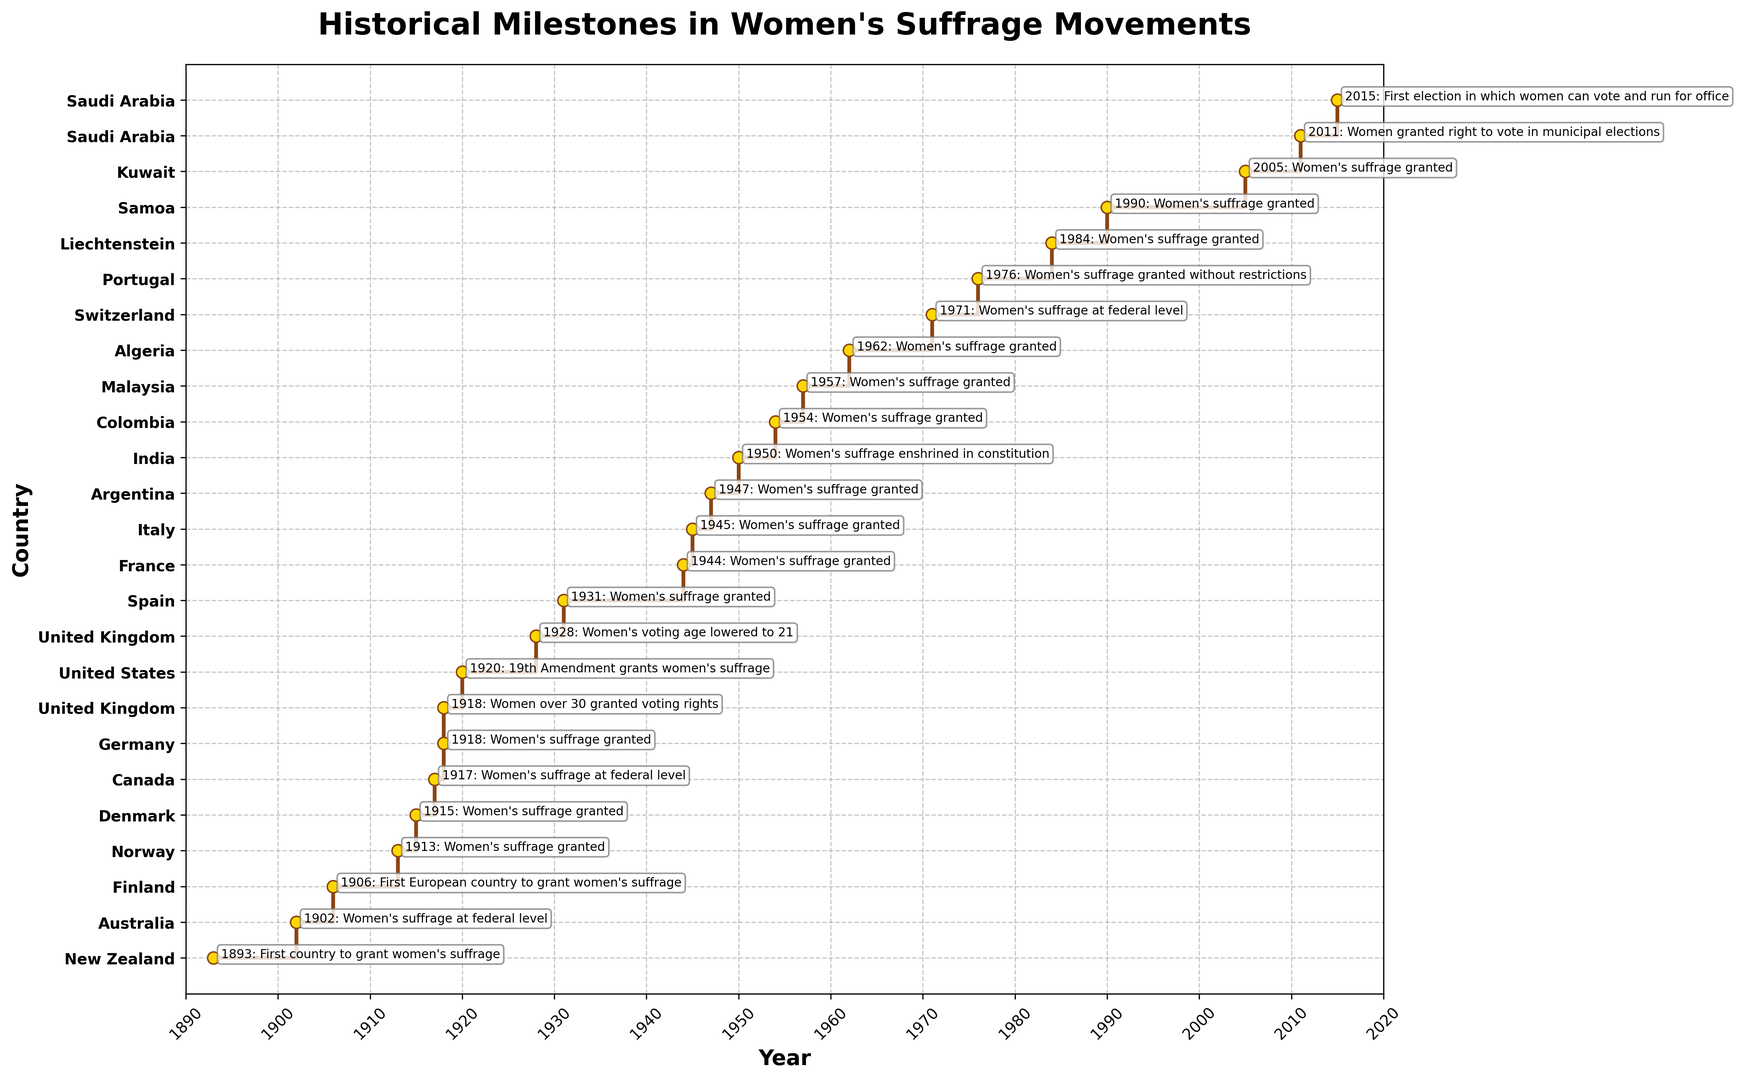Which country was the first to grant women's suffrage? By looking at the earliest year on the y-axis, which is 1893, and checking the country associated with it, we see that it is New Zealand.
Answer: New Zealand In which year did women gain the right to vote for municipal elections in Saudi Arabia? From the timeline, we can find Saudi Arabia and then read the year associated with the milestone "Women granted right to vote in municipal elections", which is 2011.
Answer: 2011 Which country granted women's suffrage at the federal level last, and in what year? By looking at the countries and the descriptions (historical milestones) on the y-axis, the country which granted suffrage last at the federal level is Switzerland in 1971.
Answer: Switzerland, 1971 How many years passed between the first country to grant women's suffrage and when the United States granted it? Identify the years for New Zealand (1893) and the United States (1920), and subtract the earlier year from the later year: 1920 - 1893 = 27 years.
Answer: 27 years In what year did both Germany and the United Kingdom have milestones related to women's suffrage, and what were those milestones? Check the row for the year 1918 and see both Germany and the United Kingdom there. Germany granted women's suffrage, and the United Kingdom granted voting rights to women over 30.
Answer: 1918; Germany granted women's suffrage, the UK granted voting rights to women over 30 How many countries granted women's suffrage between 1900 and 1950? Count the number of countries associated with years between 1900 and 1950 inclusive. These countries are Australia (1902), Finland (1906), Norway (1913), Denmark (1915), Canada (1917), Germany (1918), United Kingdom (1918, 1928), United States (1920), Spain (1931), France (1944), Italy (1945), and Argentina (1947) amounting to 12.
Answer: 12 Which milestone was achieved by several countries including Australia, Canada, and Switzerland, and in which years? Look at the milestones for these countries. They were all milestones for granting suffrage at the federal level: Australia in 1902, Canada in 1917, and Switzerland in 1971.
Answer: Granting suffrage at federal level; 1902, 1917, 1971 What is the average year in which countries granted women's suffrage between 1900 and 2000? Identify the years between 1900 and 2000: 1902, 1906, 1913, 1915, 1917, 1918, 1920, 1928, 1931, 1944, 1945, 1947, 1950, 1954, 1957, 1962, 1971, 1976, 1984, 1990. Sum these years and divide by the number of years: (1902 + 1906 + 1913 + 1915 + 1917 + 1918 + 1920 + 1928 + 1931 + 1944 + 1945 + 1947 + 1950 + 1954 + 1957 + 1962 + 1971 + 1976 + 1984 + 1990) / 20 = 1940.45.
Answer: 1940.45 